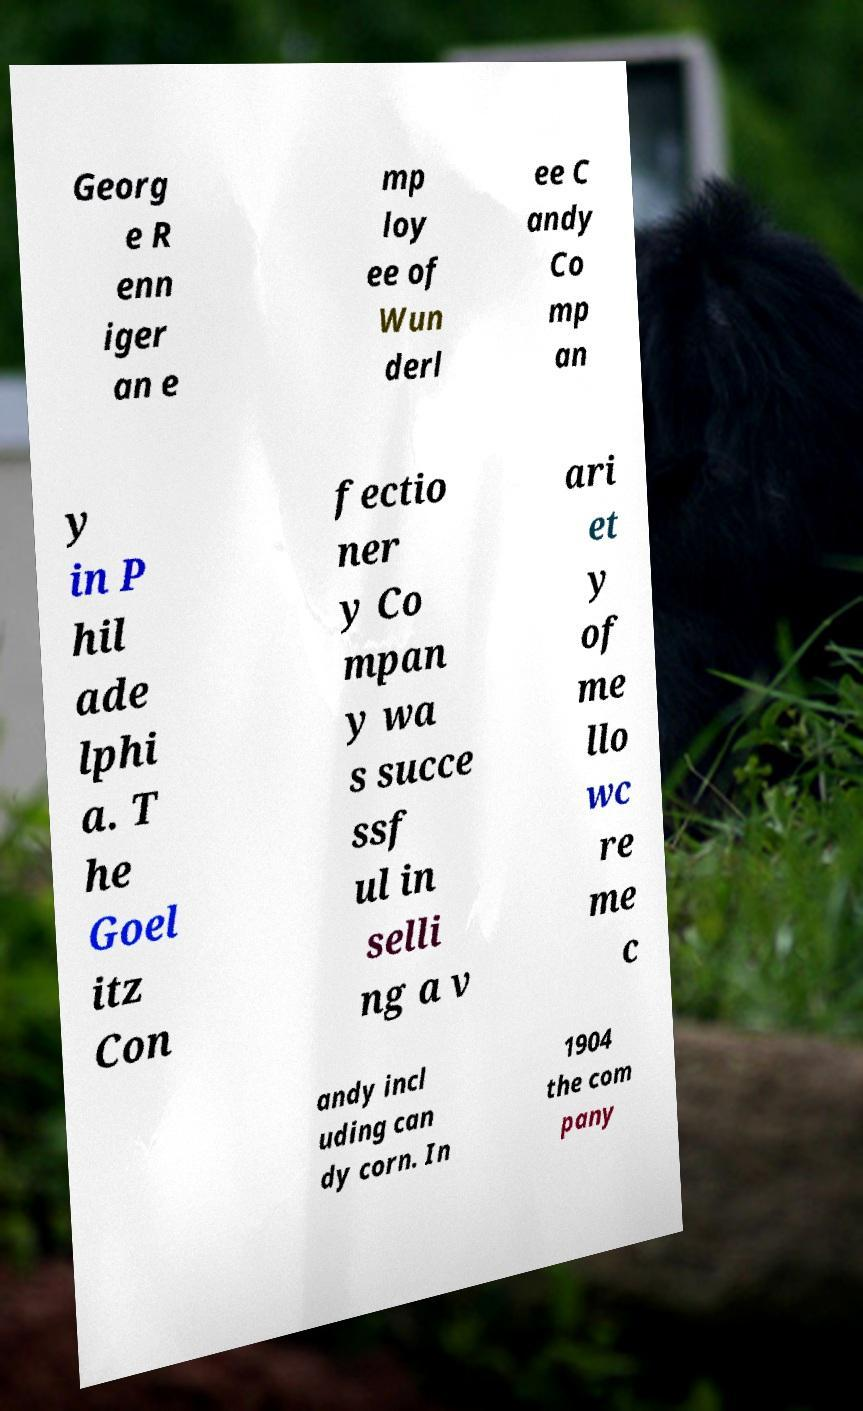I need the written content from this picture converted into text. Can you do that? Georg e R enn iger an e mp loy ee of Wun derl ee C andy Co mp an y in P hil ade lphi a. T he Goel itz Con fectio ner y Co mpan y wa s succe ssf ul in selli ng a v ari et y of me llo wc re me c andy incl uding can dy corn. In 1904 the com pany 